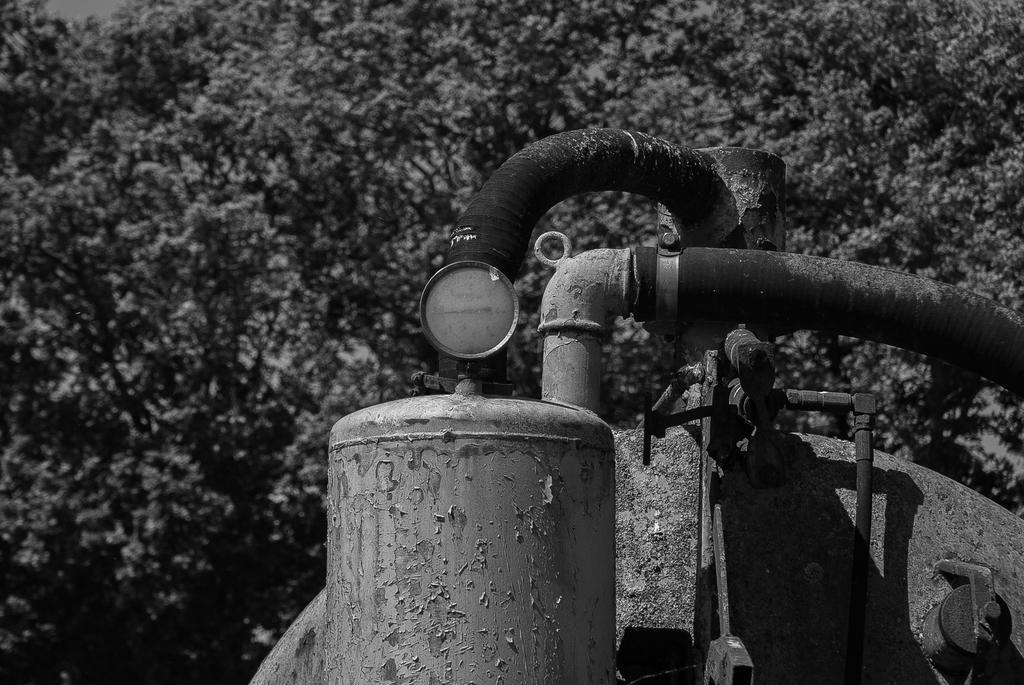Please provide a concise description of this image. In this image we can see a motor, behind trees are there. 